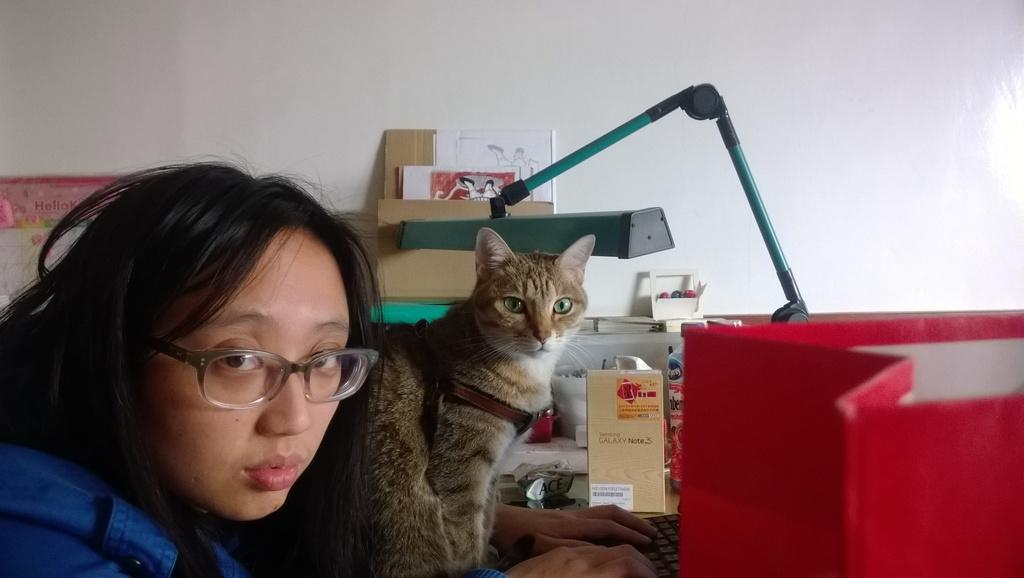Who is present in the image? There is a woman in the image. What is the woman wearing on her face? The woman is wearing spectacles. What type of animal is in the image? There is a cat in the image. What can be seen in the background of the image? There is a wall and a box in the background of the image. What type of machine is being used by the woman to improve her health in the image? There is no machine or indication of health improvement in the image; it simply features a woman, spectacles, a cat, a wall, and a box. 